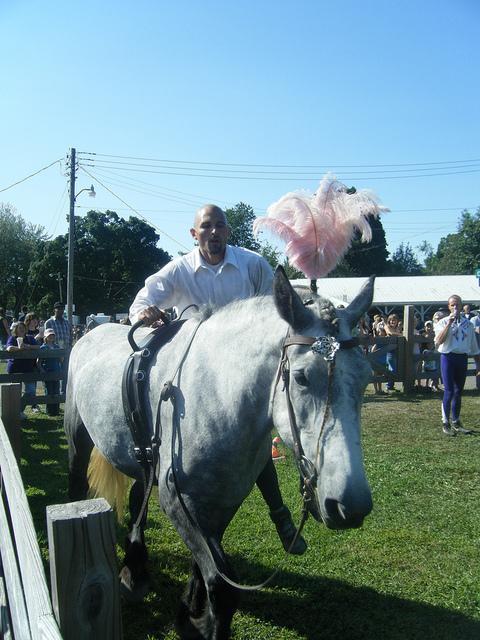How many people are there?
Give a very brief answer. 2. 